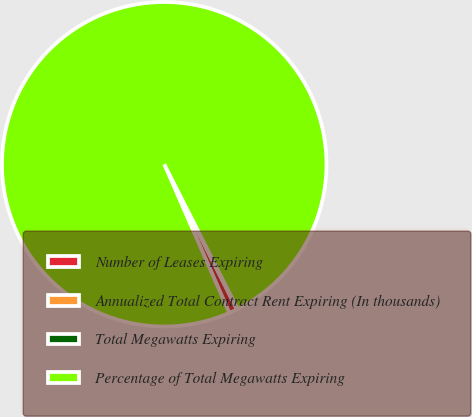<chart> <loc_0><loc_0><loc_500><loc_500><pie_chart><fcel>Number of Leases Expiring<fcel>Annualized Total Contract Rent Expiring (In thousands)<fcel>Total Megawatts Expiring<fcel>Percentage of Total Megawatts Expiring<nl><fcel>0.83%<fcel>0.04%<fcel>0.04%<fcel>99.1%<nl></chart> 